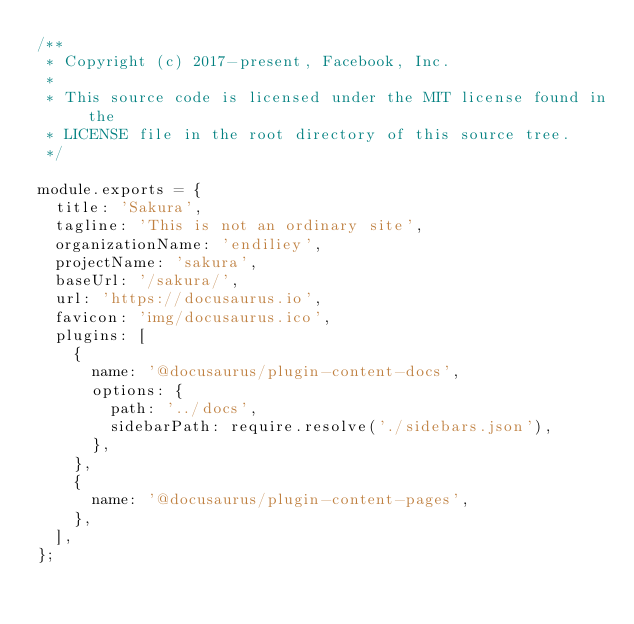<code> <loc_0><loc_0><loc_500><loc_500><_JavaScript_>/**
 * Copyright (c) 2017-present, Facebook, Inc.
 *
 * This source code is licensed under the MIT license found in the
 * LICENSE file in the root directory of this source tree.
 */

module.exports = {
  title: 'Sakura',
  tagline: 'This is not an ordinary site',
  organizationName: 'endiliey',
  projectName: 'sakura',
  baseUrl: '/sakura/',
  url: 'https://docusaurus.io',
  favicon: 'img/docusaurus.ico',
  plugins: [
    {
      name: '@docusaurus/plugin-content-docs',
      options: {
        path: '../docs',
        sidebarPath: require.resolve('./sidebars.json'),
      },
    },
    {
      name: '@docusaurus/plugin-content-pages',
    },
  ],
};
</code> 